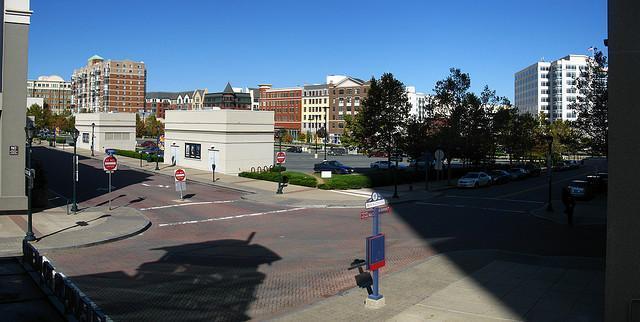How many trains have lights on?
Give a very brief answer. 0. 